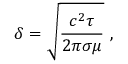<formula> <loc_0><loc_0><loc_500><loc_500>\delta = \sqrt { \frac { c ^ { 2 } \tau } { 2 \pi \sigma \mu } } ,</formula> 